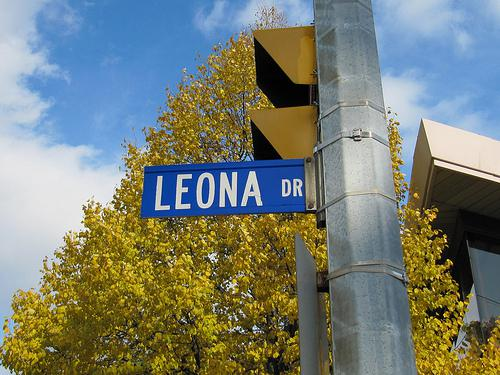Question: who is in the photo?
Choices:
A. Mom.
B. No one.
C. Girl.
D. Singer.
Answer with the letter. Answer: B 